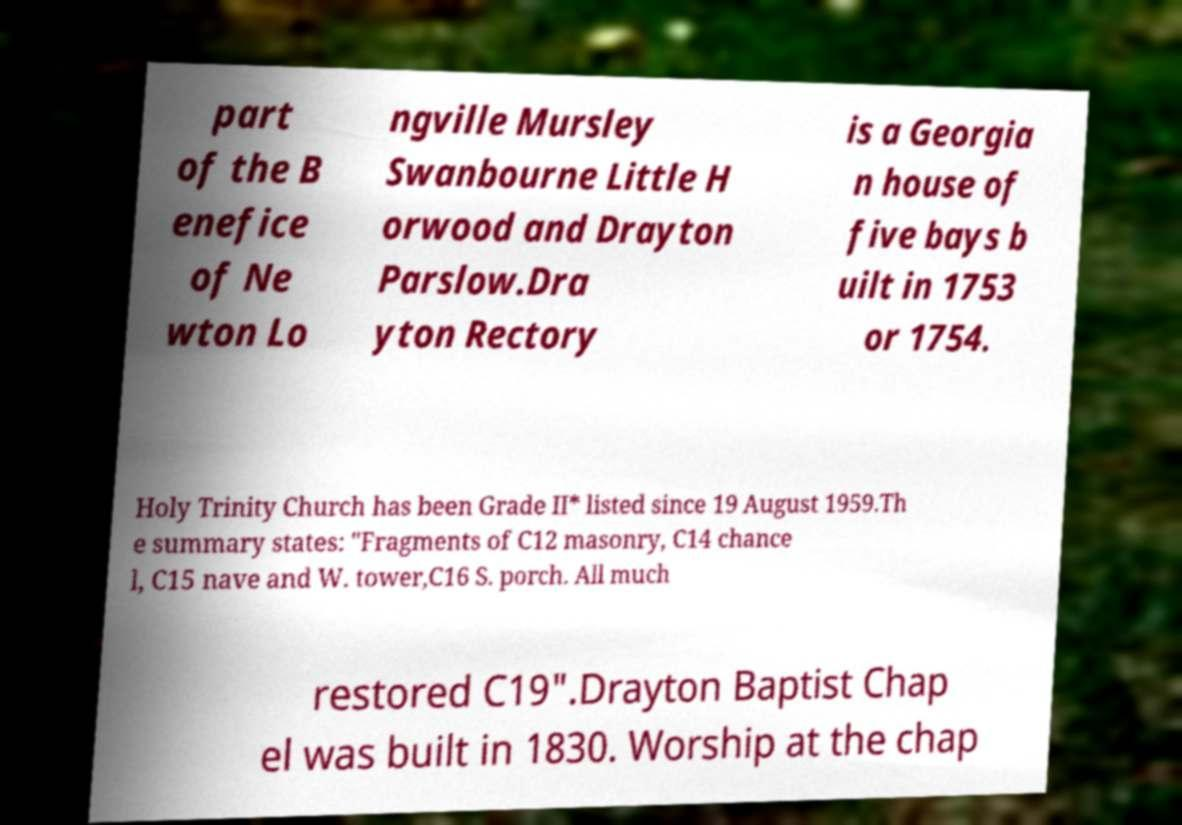Could you assist in decoding the text presented in this image and type it out clearly? part of the B enefice of Ne wton Lo ngville Mursley Swanbourne Little H orwood and Drayton Parslow.Dra yton Rectory is a Georgia n house of five bays b uilt in 1753 or 1754. Holy Trinity Church has been Grade II* listed since 19 August 1959.Th e summary states: "Fragments of C12 masonry, C14 chance l, C15 nave and W. tower,C16 S. porch. All much restored C19".Drayton Baptist Chap el was built in 1830. Worship at the chap 